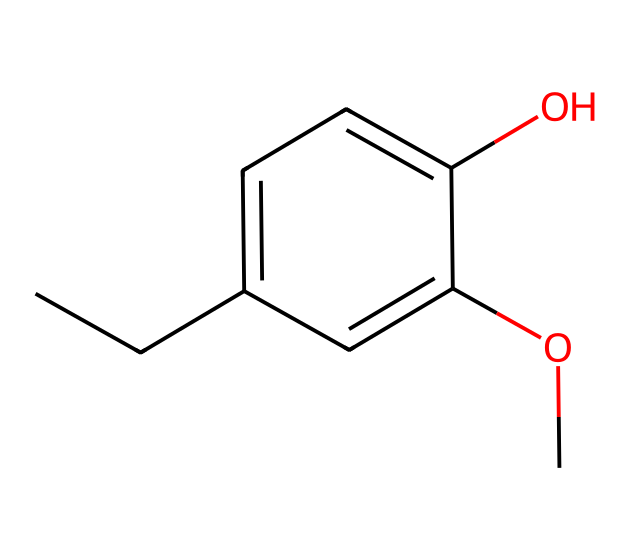What is the name of this chemical? The chemical structure corresponds to eugenol, which is recognizable due to the specific arrangement of carbon, oxygen, and hydrogen atoms noted in the SMILES representation and known from chemistry literature.
Answer: eugenol How many carbon atoms are in eugenol? Counting the carbon atoms in the SMILES representation, there are 10 carbon atoms indicated by the 'C' symbols in the structure.
Answer: 10 What functional groups are present in eugenol? Analyzing the structure, eugenol contains both a phenolic hydroxyl group (-OH) and a methoxy group (-OCH3), which are indicated in the SMILES system.
Answer: hydroxyl and methoxy What type of ether structure is present in eugenol? In eugenol, the ether structure arises from the methoxy group (-OCH3) which is a simple ether linked to the aromatic system, highlighting its classification within ethers.
Answer: simple ether How many oxygen atoms are present in eugenol? The SMILES representation reveals two oxygen atoms in total: one in the hydroxyl group and one in the methoxy group, confirming the count.
Answer: 2 Is eugenol soluble in organic solvents? Given the presence of non-polar carbon chains along with the polar functional groups, eugenol typically exhibits solubility in organic solvents such as ethanol and ether.
Answer: yes What is the primary use of eugenol in the culinary context? In culinary applications, eugenol is widely used as a flavoring agent due to its aromatic properties and is often found in various spices and cured meats.
Answer: flavoring agent 